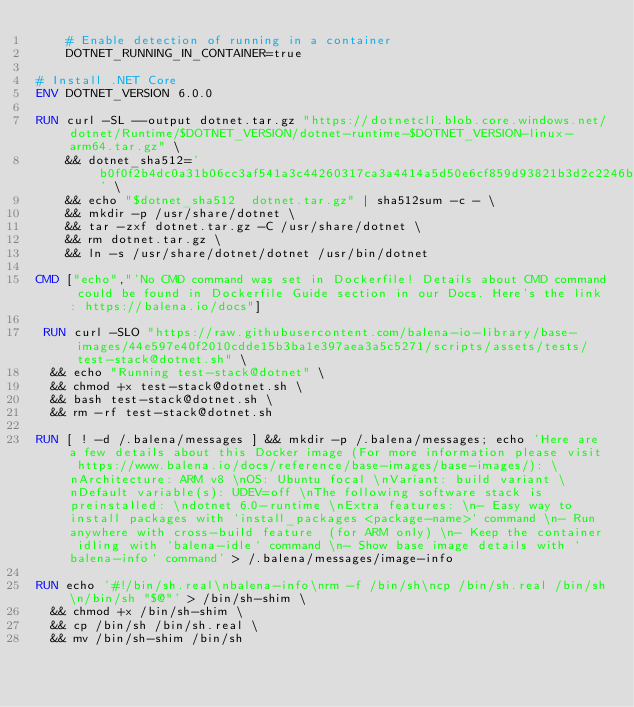<code> <loc_0><loc_0><loc_500><loc_500><_Dockerfile_>    # Enable detection of running in a container
    DOTNET_RUNNING_IN_CONTAINER=true

# Install .NET Core
ENV DOTNET_VERSION 6.0.0

RUN curl -SL --output dotnet.tar.gz "https://dotnetcli.blob.core.windows.net/dotnet/Runtime/$DOTNET_VERSION/dotnet-runtime-$DOTNET_VERSION-linux-arm64.tar.gz" \
    && dotnet_sha512='b0f0f2b4dc0a31b06cc3af541a3c44260317ca3a4414a5d50e6cf859d93821b3d2c2246baec9f96004aeb1eb0e353631283b11cf3acc134d4694f0ed71c9503d' \
    && echo "$dotnet_sha512  dotnet.tar.gz" | sha512sum -c - \
    && mkdir -p /usr/share/dotnet \
    && tar -zxf dotnet.tar.gz -C /usr/share/dotnet \
    && rm dotnet.tar.gz \
    && ln -s /usr/share/dotnet/dotnet /usr/bin/dotnet

CMD ["echo","'No CMD command was set in Dockerfile! Details about CMD command could be found in Dockerfile Guide section in our Docs. Here's the link: https://balena.io/docs"]

 RUN curl -SLO "https://raw.githubusercontent.com/balena-io-library/base-images/44e597e40f2010cdde15b3ba1e397aea3a5c5271/scripts/assets/tests/test-stack@dotnet.sh" \
  && echo "Running test-stack@dotnet" \
  && chmod +x test-stack@dotnet.sh \
  && bash test-stack@dotnet.sh \
  && rm -rf test-stack@dotnet.sh 

RUN [ ! -d /.balena/messages ] && mkdir -p /.balena/messages; echo 'Here are a few details about this Docker image (For more information please visit https://www.balena.io/docs/reference/base-images/base-images/): \nArchitecture: ARM v8 \nOS: Ubuntu focal \nVariant: build variant \nDefault variable(s): UDEV=off \nThe following software stack is preinstalled: \ndotnet 6.0-runtime \nExtra features: \n- Easy way to install packages with `install_packages <package-name>` command \n- Run anywhere with cross-build feature  (for ARM only) \n- Keep the container idling with `balena-idle` command \n- Show base image details with `balena-info` command' > /.balena/messages/image-info

RUN echo '#!/bin/sh.real\nbalena-info\nrm -f /bin/sh\ncp /bin/sh.real /bin/sh\n/bin/sh "$@"' > /bin/sh-shim \
	&& chmod +x /bin/sh-shim \
	&& cp /bin/sh /bin/sh.real \
	&& mv /bin/sh-shim /bin/sh</code> 